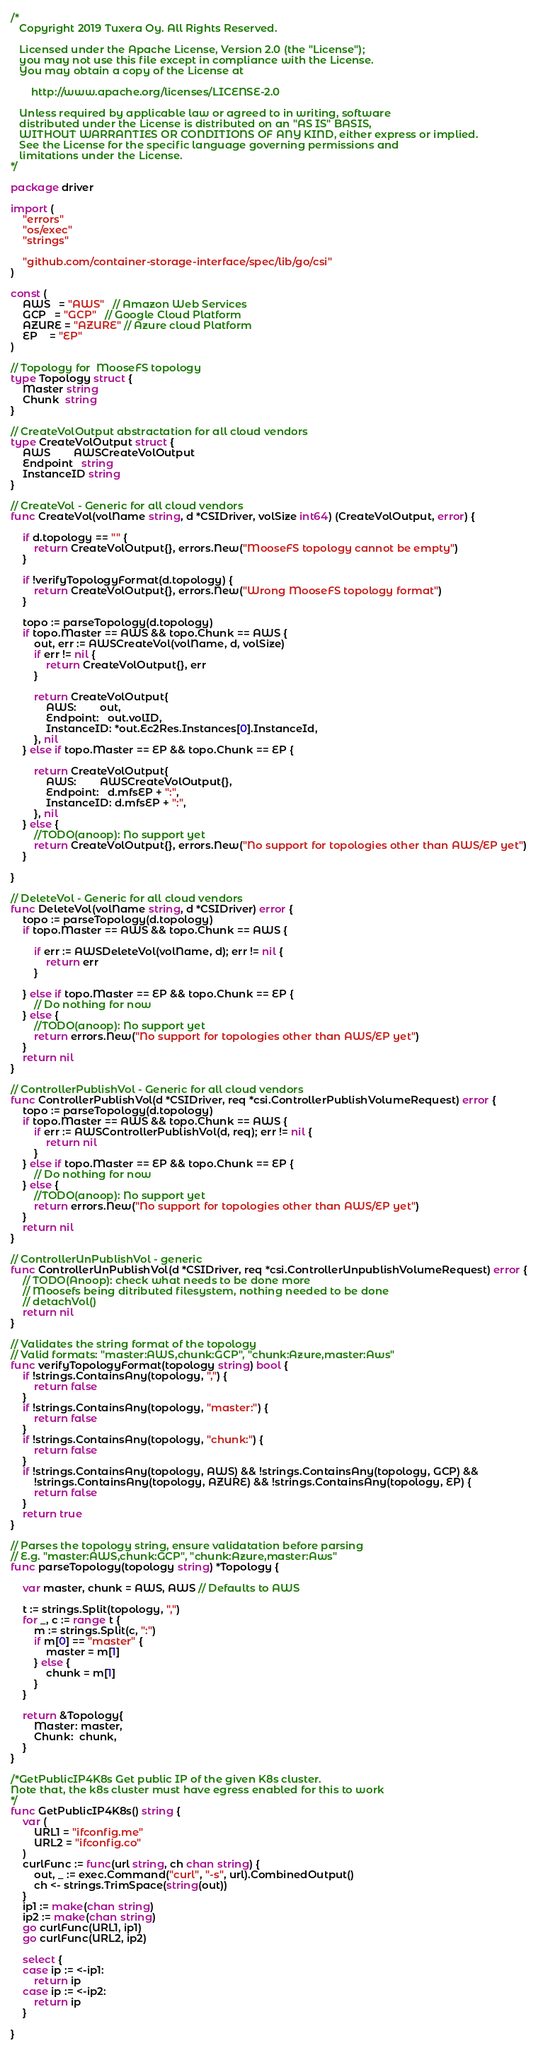Convert code to text. <code><loc_0><loc_0><loc_500><loc_500><_Go_>/*
   Copyright 2019 Tuxera Oy. All Rights Reserved.

   Licensed under the Apache License, Version 2.0 (the "License");
   you may not use this file except in compliance with the License.
   You may obtain a copy of the License at

       http://www.apache.org/licenses/LICENSE-2.0

   Unless required by applicable law or agreed to in writing, software
   distributed under the License is distributed on an "AS IS" BASIS,
   WITHOUT WARRANTIES OR CONDITIONS OF ANY KIND, either express or implied.
   See the License for the specific language governing permissions and
   limitations under the License.
*/

package driver

import (
	"errors"
	"os/exec"
	"strings"

	"github.com/container-storage-interface/spec/lib/go/csi"
)

const (
	AWS   = "AWS"   // Amazon Web Services
	GCP   = "GCP"   // Google Cloud Platform
	AZURE = "AZURE" // Azure cloud Platform
	EP    = "EP"
)

// Topology for  MooseFS topology
type Topology struct {
	Master string
	Chunk  string
}

// CreateVolOutput abstractation for all cloud vendors
type CreateVolOutput struct {
	AWS        AWSCreateVolOutput
	Endpoint   string
	InstanceID string
}

// CreateVol - Generic for all cloud vendors
func CreateVol(volName string, d *CSIDriver, volSize int64) (CreateVolOutput, error) {

	if d.topology == "" {
		return CreateVolOutput{}, errors.New("MooseFS topology cannot be empty")
	}

	if !verifyTopologyFormat(d.topology) {
		return CreateVolOutput{}, errors.New("Wrong MooseFS topology format")
	}

	topo := parseTopology(d.topology)
	if topo.Master == AWS && topo.Chunk == AWS {
		out, err := AWSCreateVol(volName, d, volSize)
		if err != nil {
			return CreateVolOutput{}, err
		}

		return CreateVolOutput{
			AWS:        out,
			Endpoint:   out.volID,
			InstanceID: *out.Ec2Res.Instances[0].InstanceId,
		}, nil
	} else if topo.Master == EP && topo.Chunk == EP {

		return CreateVolOutput{
			AWS:        AWSCreateVolOutput{},
			Endpoint:   d.mfsEP + ":",
			InstanceID: d.mfsEP + ":",
		}, nil
	} else {
		//TODO(anoop): No support yet
		return CreateVolOutput{}, errors.New("No support for topologies other than AWS/EP yet")
	}

}

// DeleteVol - Generic for all cloud vendors
func DeleteVol(volName string, d *CSIDriver) error {
	topo := parseTopology(d.topology)
	if topo.Master == AWS && topo.Chunk == AWS {

		if err := AWSDeleteVol(volName, d); err != nil {
			return err
		}

	} else if topo.Master == EP && topo.Chunk == EP {
		// Do nothing for now
	} else {
		//TODO(anoop): No support yet
		return errors.New("No support for topologies other than AWS/EP yet")
	}
	return nil
}

// ControllerPublishVol - Generic for all cloud vendors
func ControllerPublishVol(d *CSIDriver, req *csi.ControllerPublishVolumeRequest) error {
	topo := parseTopology(d.topology)
	if topo.Master == AWS && topo.Chunk == AWS {
		if err := AWSControllerPublishVol(d, req); err != nil {
			return nil
		}
	} else if topo.Master == EP && topo.Chunk == EP {
		// Do nothing for now
	} else {
		//TODO(anoop): No support yet
		return errors.New("No support for topologies other than AWS/EP yet")
	}
	return nil
}

// ControllerUnPublishVol - generic
func ControllerUnPublishVol(d *CSIDriver, req *csi.ControllerUnpublishVolumeRequest) error {
	// TODO(Anoop): check what needs to be done more
	// Moosefs being ditributed filesystem, nothing needed to be done
	// detachVol()
	return nil
}

// Validates the string format of the topology
// Valid formats: "master:AWS,chunk:GCP", "chunk:Azure,master:Aws"
func verifyTopologyFormat(topology string) bool {
	if !strings.ContainsAny(topology, ",") {
		return false
	}
	if !strings.ContainsAny(topology, "master:") {
		return false
	}
	if !strings.ContainsAny(topology, "chunk:") {
		return false
	}
	if !strings.ContainsAny(topology, AWS) && !strings.ContainsAny(topology, GCP) &&
		!strings.ContainsAny(topology, AZURE) && !strings.ContainsAny(topology, EP) {
		return false
	}
	return true
}

// Parses the topology string, ensure validatation before parsing
// E.g. "master:AWS,chunk:GCP", "chunk:Azure,master:Aws"
func parseTopology(topology string) *Topology {

	var master, chunk = AWS, AWS // Defaults to AWS

	t := strings.Split(topology, ",")
	for _, c := range t {
		m := strings.Split(c, ":")
		if m[0] == "master" {
			master = m[1]
		} else {
			chunk = m[1]
		}
	}

	return &Topology{
		Master: master,
		Chunk:  chunk,
	}
}

/*GetPublicIP4K8s Get public IP of the given K8s cluster.
Note that, the k8s cluster must have egress enabled for this to work
*/
func GetPublicIP4K8s() string {
	var (
		URL1 = "ifconfig.me"
		URL2 = "ifconfig.co"
	)
	curlFunc := func(url string, ch chan string) {
		out, _ := exec.Command("curl", "-s", url).CombinedOutput()
		ch <- strings.TrimSpace(string(out))
	}
	ip1 := make(chan string)
	ip2 := make(chan string)
	go curlFunc(URL1, ip1)
	go curlFunc(URL2, ip2)

	select {
	case ip := <-ip1:
		return ip
	case ip := <-ip2:
		return ip
	}

}
</code> 